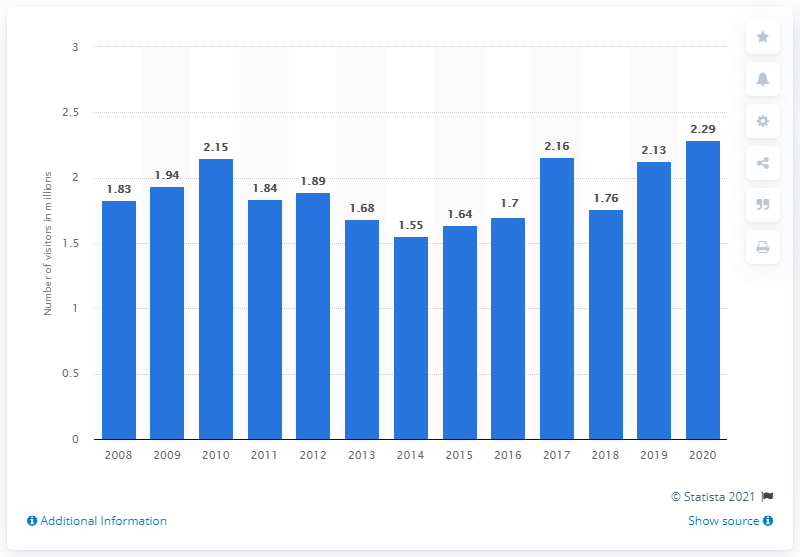Highlight a few significant elements in this photo. In 2020, there were 2,290 visitors to Indiana Dunes National Lakeshore. 